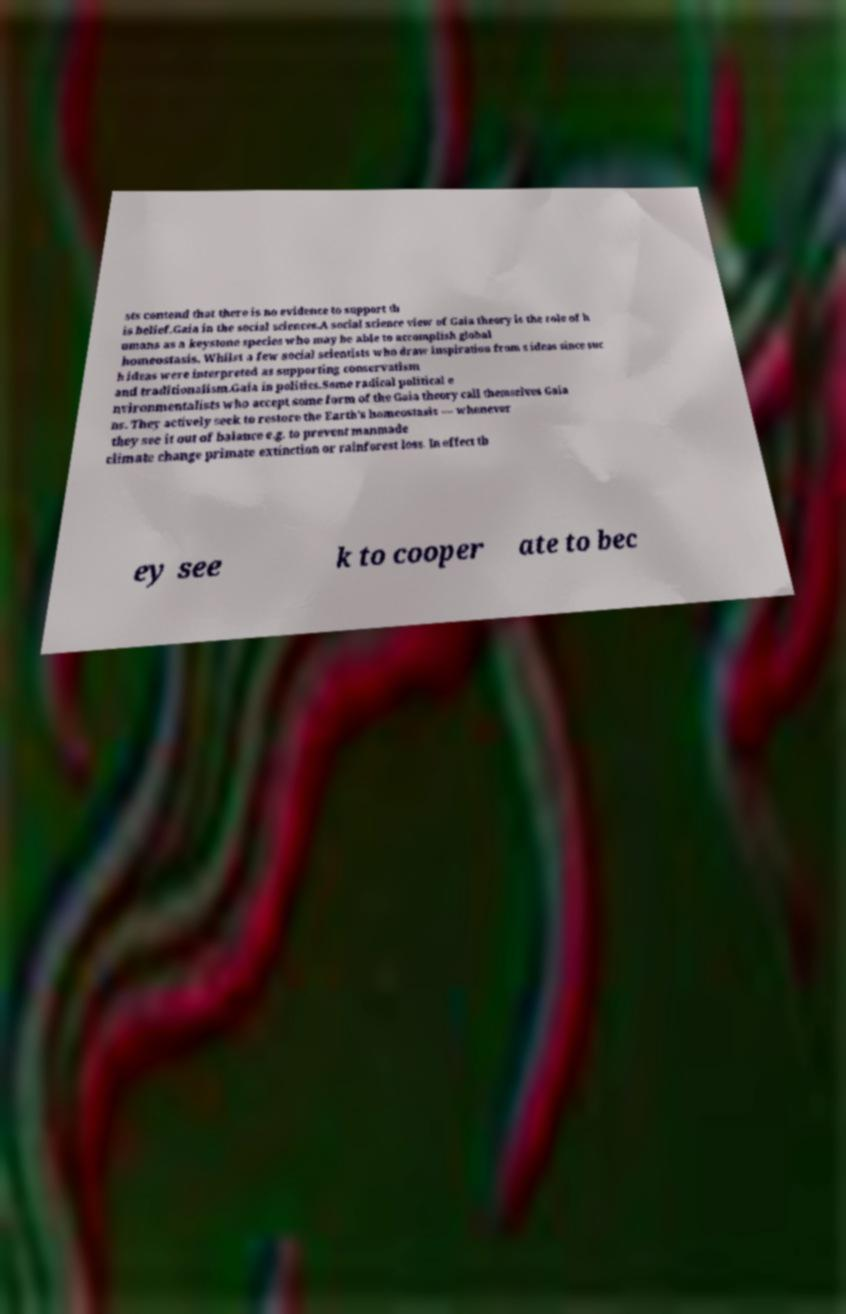Could you assist in decoding the text presented in this image and type it out clearly? sts contend that there is no evidence to support th is belief.Gaia in the social sciences.A social science view of Gaia theory is the role of h umans as a keystone species who may be able to accomplish global homeostasis. Whilst a few social scientists who draw inspiration from s ideas since suc h ideas were interpreted as supporting conservatism and traditionalism.Gaia in politics.Some radical political e nvironmentalists who accept some form of the Gaia theory call themselves Gaia ns. They actively seek to restore the Earth's homeostasis — whenever they see it out of balance e.g. to prevent manmade climate change primate extinction or rainforest loss. In effect th ey see k to cooper ate to bec 